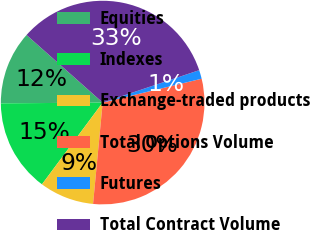Convert chart to OTSL. <chart><loc_0><loc_0><loc_500><loc_500><pie_chart><fcel>Equities<fcel>Indexes<fcel>Exchange-traded products<fcel>Total Options Volume<fcel>Futures<fcel>Total Contract Volume<nl><fcel>11.68%<fcel>14.71%<fcel>8.66%<fcel>30.27%<fcel>1.39%<fcel>33.29%<nl></chart> 